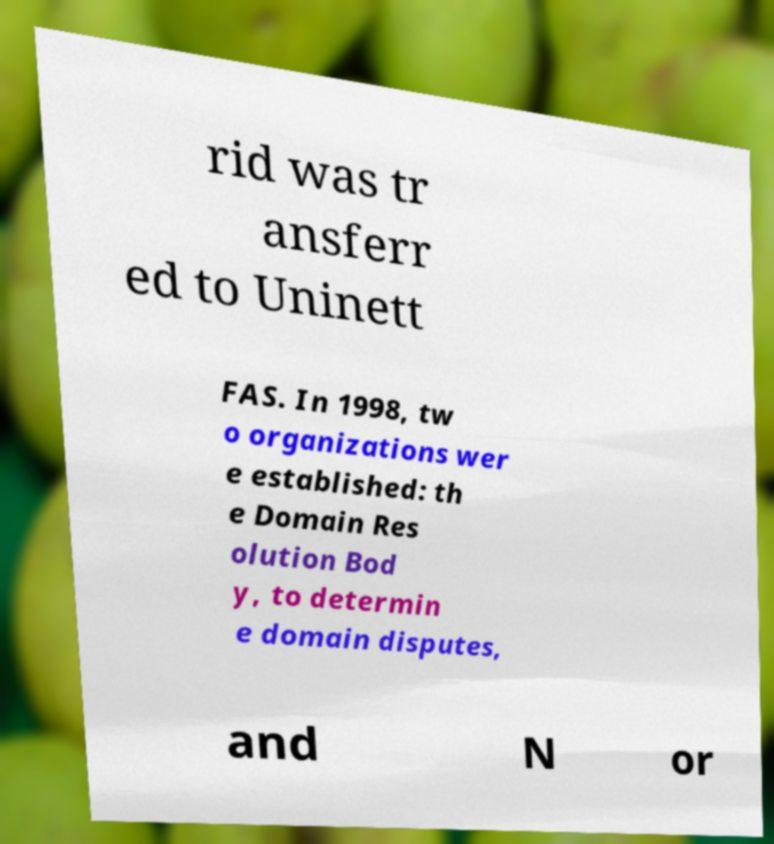Could you assist in decoding the text presented in this image and type it out clearly? rid was tr ansferr ed to Uninett FAS. In 1998, tw o organizations wer e established: th e Domain Res olution Bod y, to determin e domain disputes, and N or 